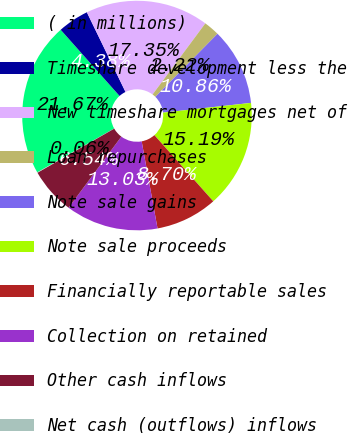Convert chart. <chart><loc_0><loc_0><loc_500><loc_500><pie_chart><fcel>( in millions)<fcel>Timeshare development less the<fcel>New timeshare mortgages net of<fcel>Loan repurchases<fcel>Note sale gains<fcel>Note sale proceeds<fcel>Financially reportable sales<fcel>Collection on retained<fcel>Other cash inflows<fcel>Net cash (outflows) inflows<nl><fcel>21.66%<fcel>4.38%<fcel>17.34%<fcel>2.22%<fcel>10.86%<fcel>15.18%<fcel>8.7%<fcel>13.02%<fcel>6.54%<fcel>0.06%<nl></chart> 